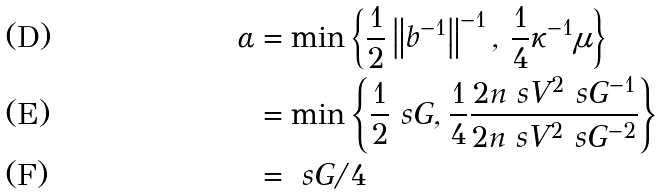Convert formula to latex. <formula><loc_0><loc_0><loc_500><loc_500>\alpha & = \min \left \{ \frac { 1 } { 2 } \left \| b ^ { - 1 } \right \| ^ { - 1 } , \, \frac { 1 } { 4 } \kappa ^ { - 1 } \mu \right \} \\ & = \min \left \{ \frac { 1 } { 2 } \ s G , \frac { 1 } { 4 } \frac { 2 n \ s V ^ { 2 } \ s G ^ { - 1 } } { 2 n \ s V ^ { 2 } \ s G ^ { - 2 } } \right \} \\ & = \ s G / 4</formula> 